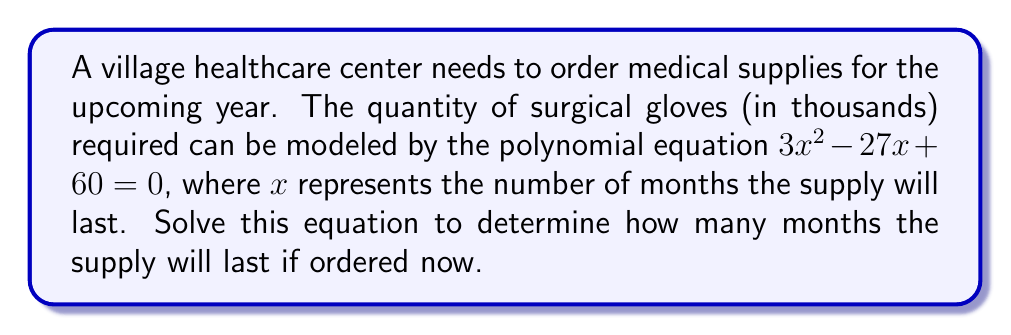Help me with this question. To solve this polynomial equation, we'll use the quadratic formula:

For a quadratic equation in the form $ax^2 + bx + c = 0$,
The solution is given by $x = \frac{-b \pm \sqrt{b^2 - 4ac}}{2a}$

In our equation $3x^2 - 27x + 60 = 0$:
$a = 3$
$b = -27$
$c = 60$

Let's substitute these values into the quadratic formula:

$$x = \frac{-(-27) \pm \sqrt{(-27)^2 - 4(3)(60)}}{2(3)}$$

Simplifying:

$$x = \frac{27 \pm \sqrt{729 - 720}}{6}$$

$$x = \frac{27 \pm \sqrt{9}}{6}$$

$$x = \frac{27 \pm 3}{6}$$

This gives us two solutions:

$$x = \frac{27 + 3}{6} = \frac{30}{6} = 5$$

$$x = \frac{27 - 3}{6} = \frac{24}{6} = 4$$

Therefore, the supply will last either 4 or 5 months.

As a healthcare administrator, you would likely choose the smaller value (4 months) for a more conservative estimate to ensure you don't run out of supplies.
Answer: The supply of surgical gloves will last 4 months. 